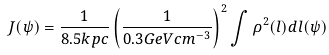Convert formula to latex. <formula><loc_0><loc_0><loc_500><loc_500>J ( \psi ) = \frac { 1 } { 8 . 5 k p c } \left ( \frac { 1 } { 0 . 3 G e V c m ^ { - 3 } } \right ) ^ { 2 } \int \rho ^ { 2 } ( l ) d l ( \psi )</formula> 